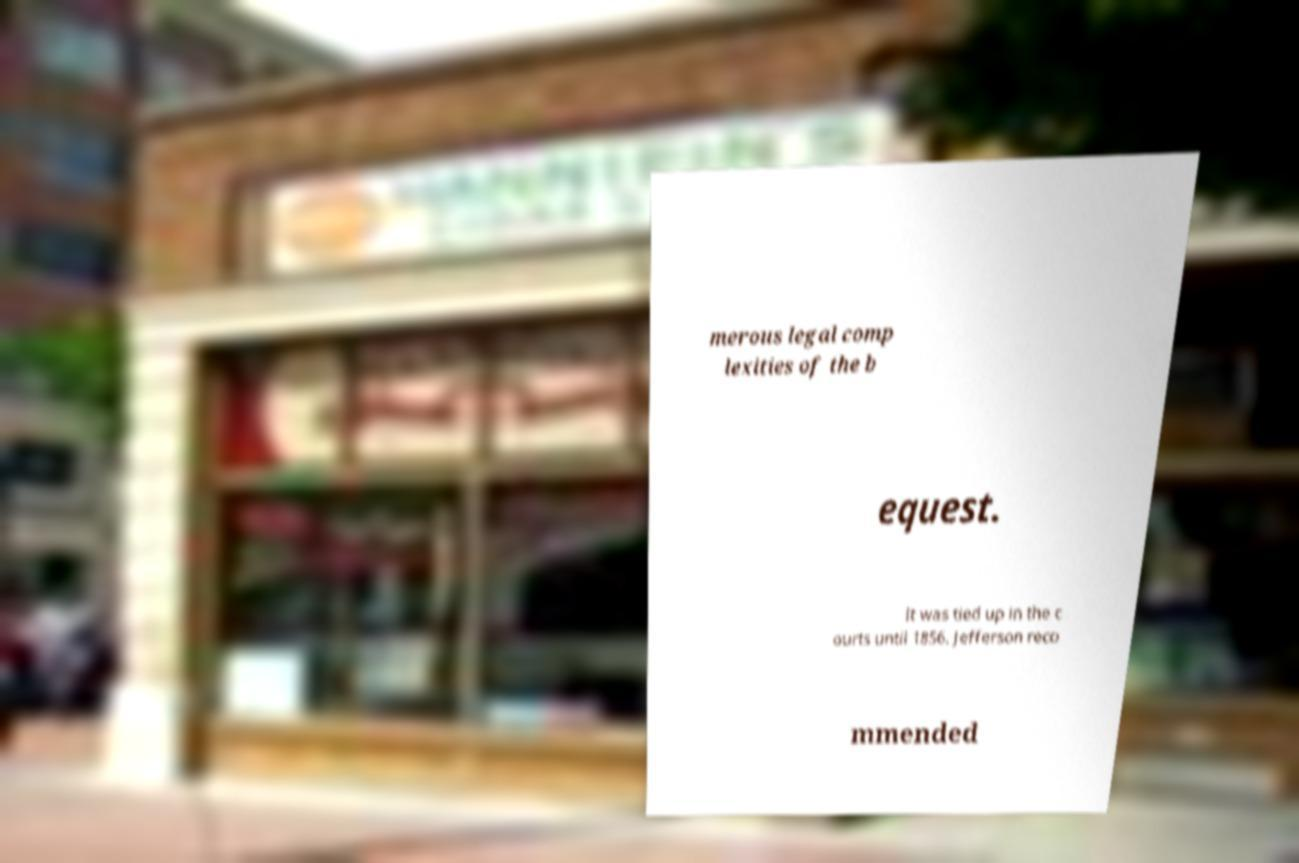Can you read and provide the text displayed in the image?This photo seems to have some interesting text. Can you extract and type it out for me? merous legal comp lexities of the b equest. It was tied up in the c ourts until 1856. Jefferson reco mmended 